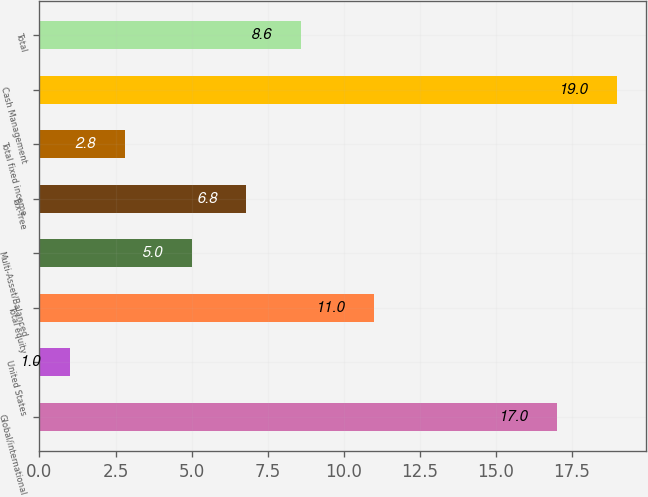Convert chart. <chart><loc_0><loc_0><loc_500><loc_500><bar_chart><fcel>Global/international<fcel>United States<fcel>Total equity<fcel>Multi-Asset/Balanced<fcel>Tax-free<fcel>Total fixed income<fcel>Cash Management<fcel>Total<nl><fcel>17<fcel>1<fcel>11<fcel>5<fcel>6.8<fcel>2.8<fcel>19<fcel>8.6<nl></chart> 